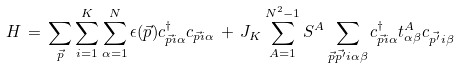<formula> <loc_0><loc_0><loc_500><loc_500>H \, = \, \sum _ { \vec { p } } \sum _ { i = 1 } ^ { K } \sum _ { \alpha = 1 } ^ { N } \epsilon ( \vec { p } ) c ^ { \dagger } _ { \vec { p } i \alpha } c _ { \vec { p } i \alpha } \, + \, J _ { K } \sum _ { A = 1 } ^ { N ^ { 2 } - 1 } S ^ { A } \sum _ { \vec { p } \vec { p ^ { \prime } } i \alpha \beta } c ^ { \dagger } _ { \vec { p } i \alpha } t ^ { A } _ { \alpha \beta } c _ { \vec { p ^ { \prime } } i \beta }</formula> 